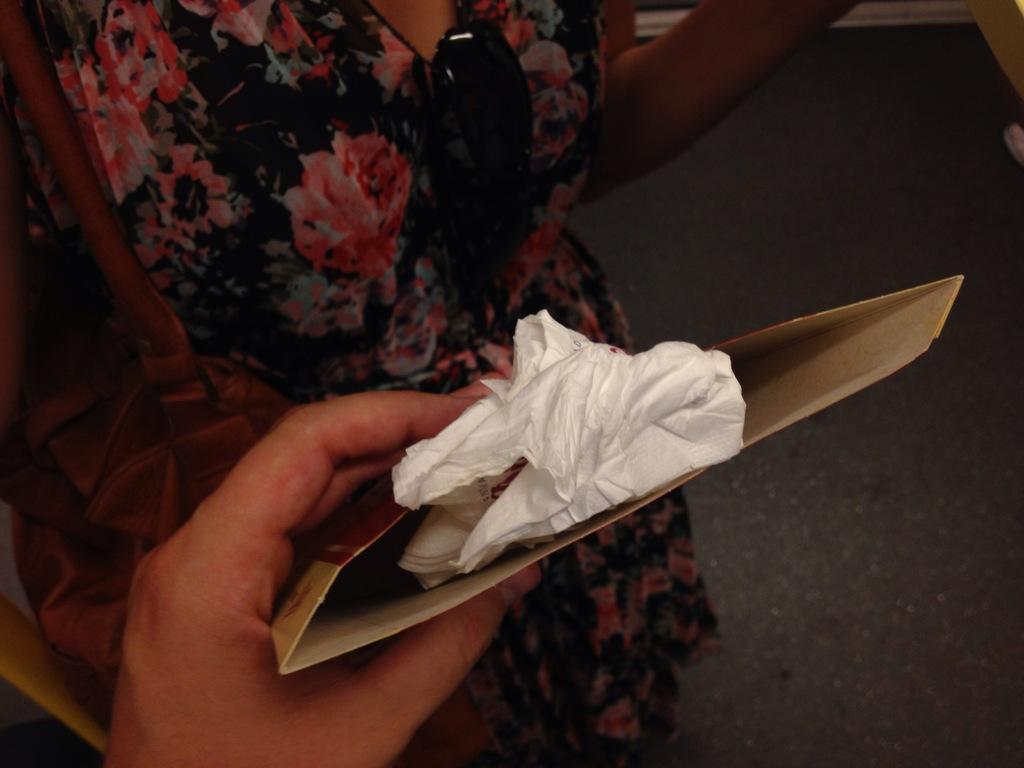Please provide a concise description of this image. As we can see in the image there is a woman wearing black color dress and holding bag. In the front there is a hand holding cover. 